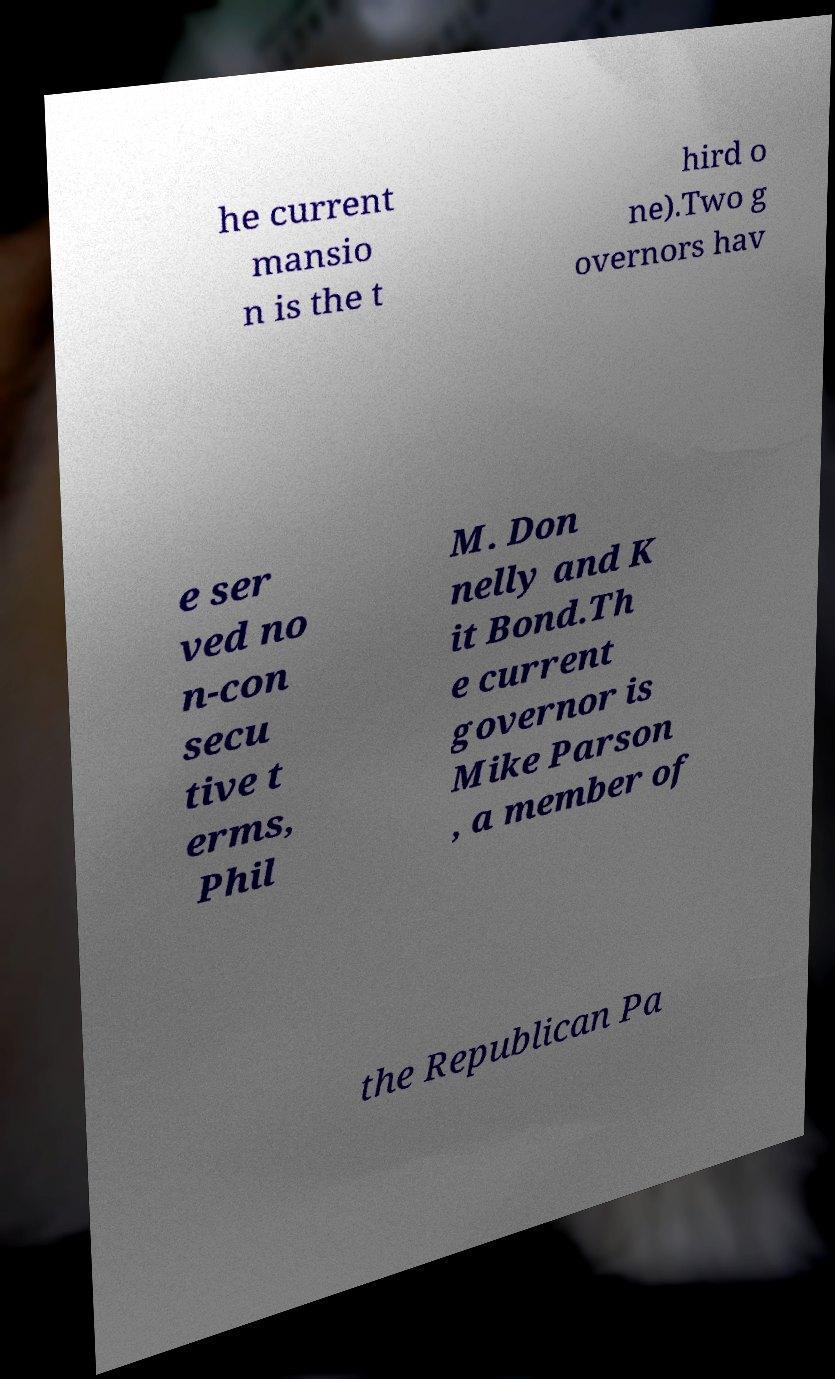What messages or text are displayed in this image? I need them in a readable, typed format. he current mansio n is the t hird o ne).Two g overnors hav e ser ved no n-con secu tive t erms, Phil M. Don nelly and K it Bond.Th e current governor is Mike Parson , a member of the Republican Pa 